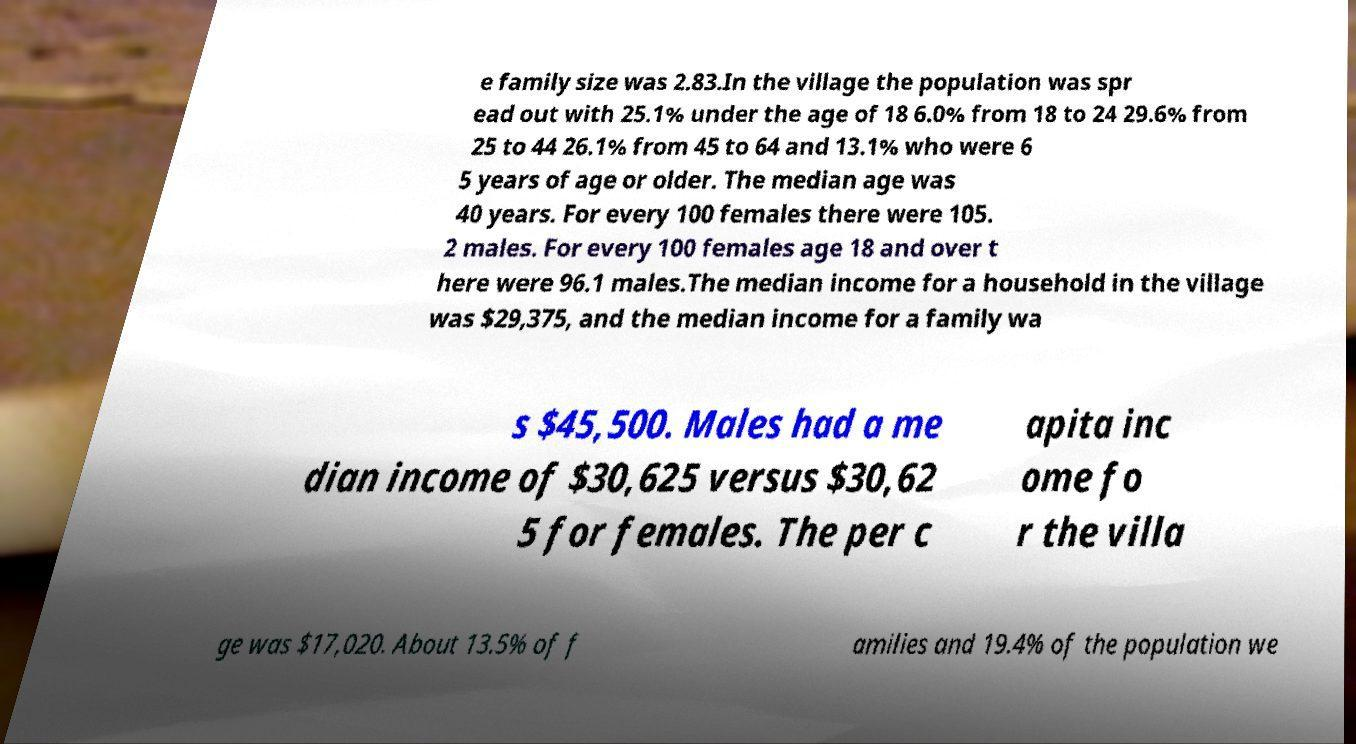Please read and relay the text visible in this image. What does it say? e family size was 2.83.In the village the population was spr ead out with 25.1% under the age of 18 6.0% from 18 to 24 29.6% from 25 to 44 26.1% from 45 to 64 and 13.1% who were 6 5 years of age or older. The median age was 40 years. For every 100 females there were 105. 2 males. For every 100 females age 18 and over t here were 96.1 males.The median income for a household in the village was $29,375, and the median income for a family wa s $45,500. Males had a me dian income of $30,625 versus $30,62 5 for females. The per c apita inc ome fo r the villa ge was $17,020. About 13.5% of f amilies and 19.4% of the population we 